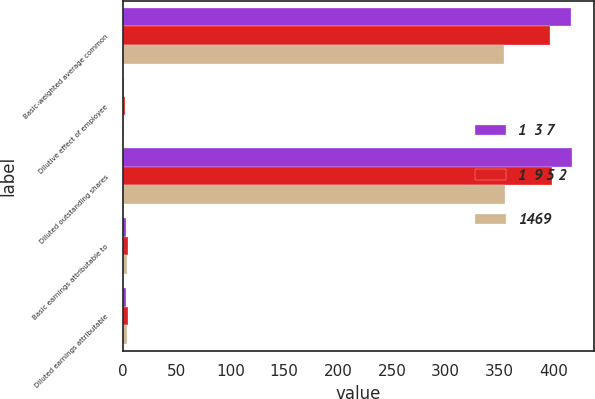Convert chart. <chart><loc_0><loc_0><loc_500><loc_500><stacked_bar_chart><ecel><fcel>Basic-weighted average common<fcel>Dilutive effect of employee<fcel>Diluted outstanding shares<fcel>Basic earnings attributable to<fcel>Diluted earnings attributable<nl><fcel>1  3 7<fcel>416<fcel>1<fcel>417<fcel>3.53<fcel>3.52<nl><fcel>1  9 5 2<fcel>397<fcel>2<fcel>399<fcel>4.91<fcel>4.9<nl><fcel>1469<fcel>354<fcel>1<fcel>355<fcel>3.77<fcel>3.76<nl></chart> 